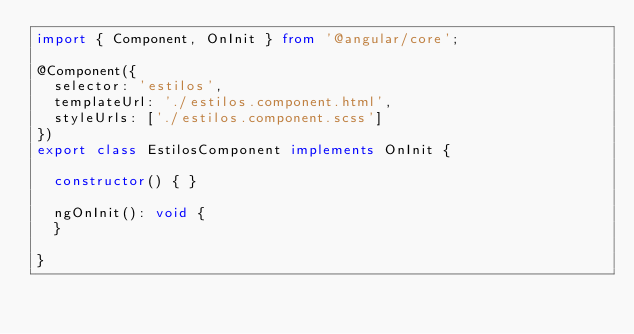Convert code to text. <code><loc_0><loc_0><loc_500><loc_500><_TypeScript_>import { Component, OnInit } from '@angular/core';

@Component({
  selector: 'estilos',
  templateUrl: './estilos.component.html',
  styleUrls: ['./estilos.component.scss']
})
export class EstilosComponent implements OnInit {

  constructor() { }

  ngOnInit(): void {
  }

}
</code> 